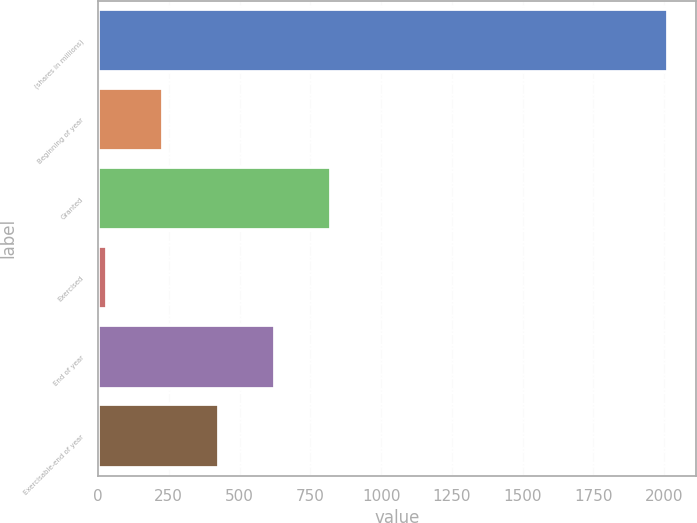<chart> <loc_0><loc_0><loc_500><loc_500><bar_chart><fcel>(shares in millions)<fcel>Beginning of year<fcel>Granted<fcel>Exercised<fcel>End of year<fcel>Exercisable-end of year<nl><fcel>2012<fcel>229.49<fcel>823.67<fcel>31.43<fcel>625.61<fcel>427.55<nl></chart> 